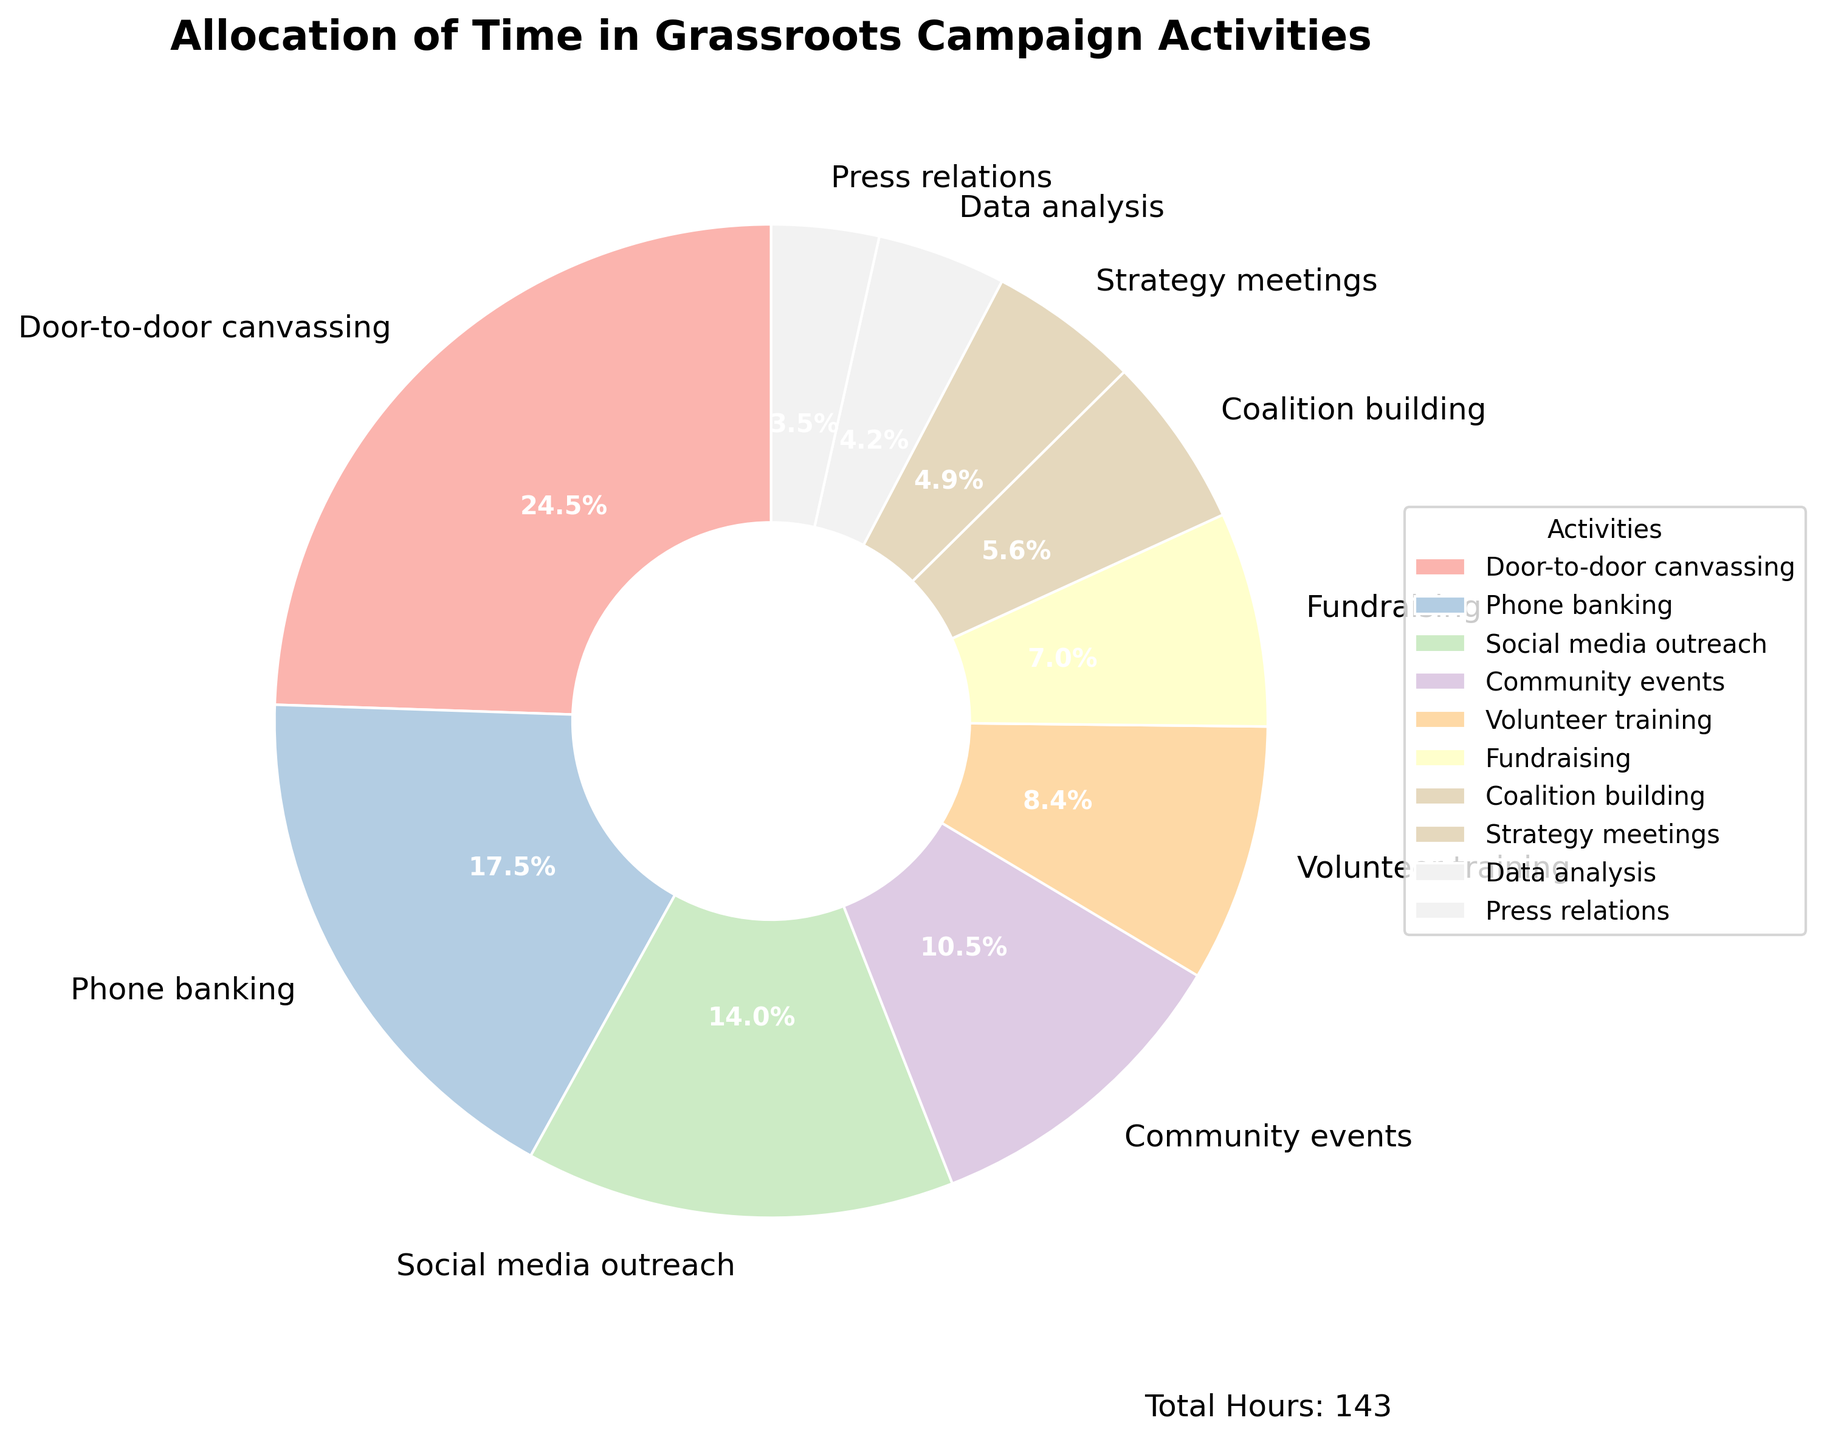What activity occupies the largest portion of the pie chart? The largest portion of the pie chart corresponds to the activity with the highest percentage. Door-to-door canvassing shows the largest wedge.
Answer: Door-to-door canvassing Which two activities together make up over 50% of the total time spent? To find this, identify the two activities with the largest percentages and sum them. Door-to-door canvassing (35%) and Phone banking (25%) together make up 60%.
Answer: Door-to-door canvassing and Phone banking How much more time is allocated to Door-to-door canvassing compared to Strategy meetings? Subtract the percentage of time spent on Strategy meetings (7%) from Door-to-door canvassing (35%). The difference is 28%.
Answer: 28% What percentage of time is spent on activities excluding Door-to-door canvassing and Phone banking? Sum the percentages of all activities and subtract the combined percentage of Door-to-door canvassing and Phone banking (35% + 25% = 60%). The remaining percentage is 40%.
Answer: 40% Compare the time spent on Social media outreach with Community events. Check the percentages for Social media outreach (20%) and Community events (15%). Social media outreach has 5% more time allocated.
Answer: Social media outreach has 5% more What is the combined percentage of time allocated to Volunteer training and Fundraising? Sum the percentages for Volunteer training (12%) and Fundraising (10%). The total is 22%.
Answer: 22% Are there more hours allocated to Data analysis or Press relations? Compare the percentages for Data analysis (6%) and Press relations (5%). Data analysis has more hours allocated.
Answer: Data analysis What activities are allocated less than 10% of the total time each? Identify activities with percentages less than 10%. These are Coalition building (8%), Strategy meetings (7%), Data analysis (6%), and Press relations (5%).
Answer: Coalition building, Strategy meetings, Data analysis, Press relations Which activity has the smallest allocation of time? The smallest wedge in the pie chart represents Press relations (5%).
Answer: Press relations 